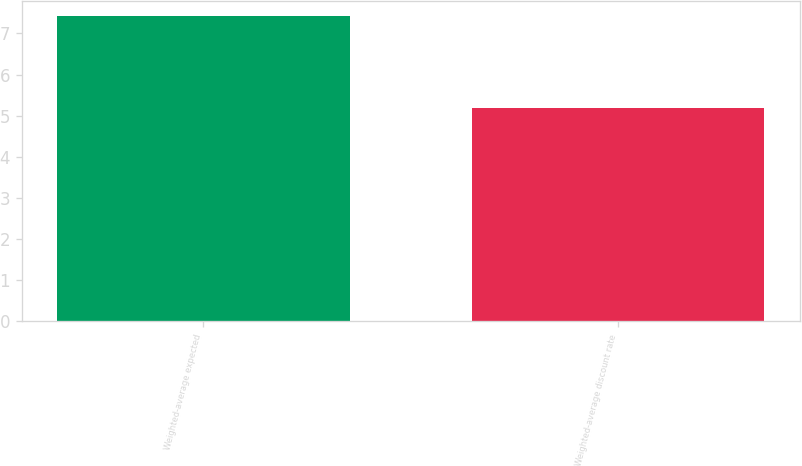Convert chart to OTSL. <chart><loc_0><loc_0><loc_500><loc_500><bar_chart><fcel>Weighted-average expected<fcel>Weighted-average discount rate<nl><fcel>7.42<fcel>5.19<nl></chart> 